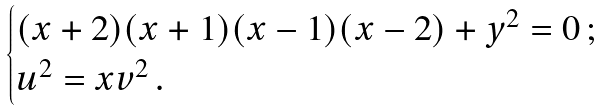<formula> <loc_0><loc_0><loc_500><loc_500>\begin{cases} ( x + 2 ) ( x + 1 ) ( x - 1 ) ( x - 2 ) + y ^ { 2 } = 0 \, ; \\ u ^ { 2 } = x v ^ { 2 } \, . \end{cases}</formula> 